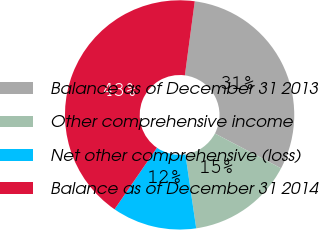Convert chart to OTSL. <chart><loc_0><loc_0><loc_500><loc_500><pie_chart><fcel>Balance as of December 31 2013<fcel>Other comprehensive income<fcel>Net other comprehensive (loss)<fcel>Balance as of December 31 2014<nl><fcel>30.6%<fcel>14.98%<fcel>11.92%<fcel>42.51%<nl></chart> 